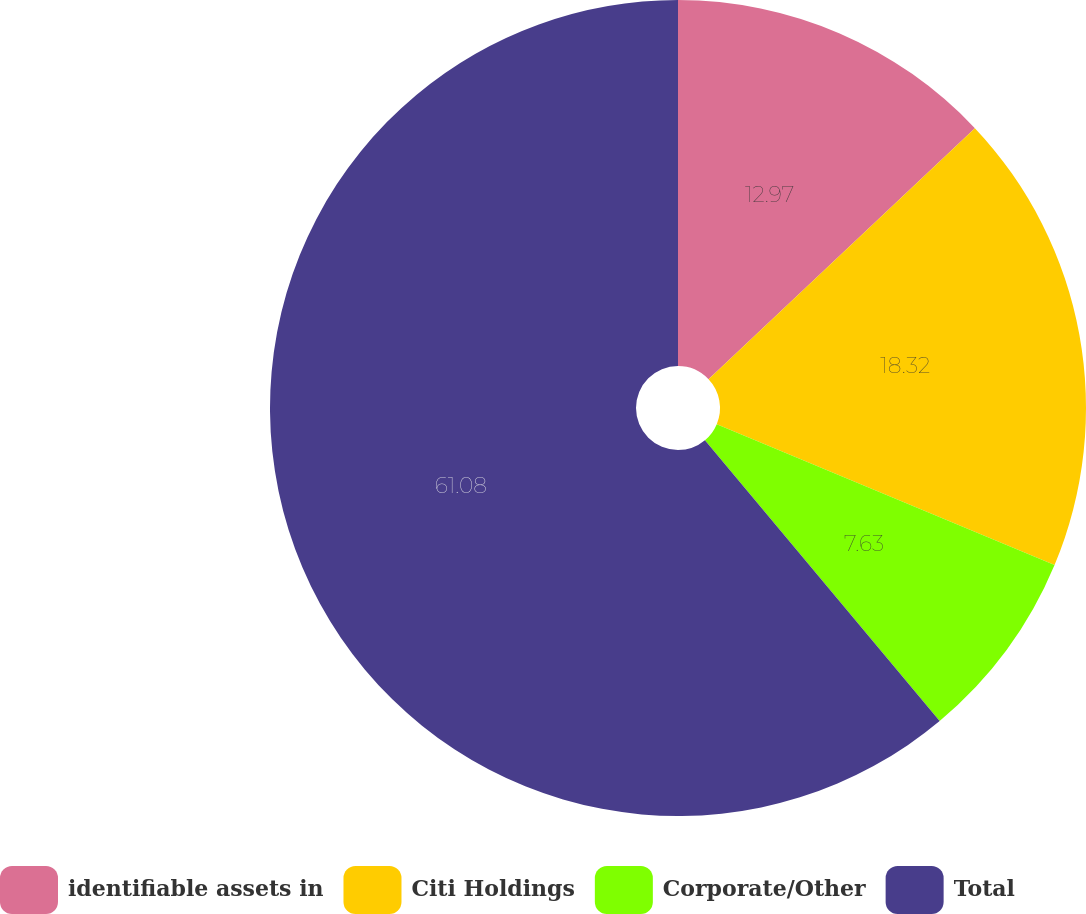Convert chart. <chart><loc_0><loc_0><loc_500><loc_500><pie_chart><fcel>identifiable assets in<fcel>Citi Holdings<fcel>Corporate/Other<fcel>Total<nl><fcel>12.97%<fcel>18.32%<fcel>7.63%<fcel>61.08%<nl></chart> 